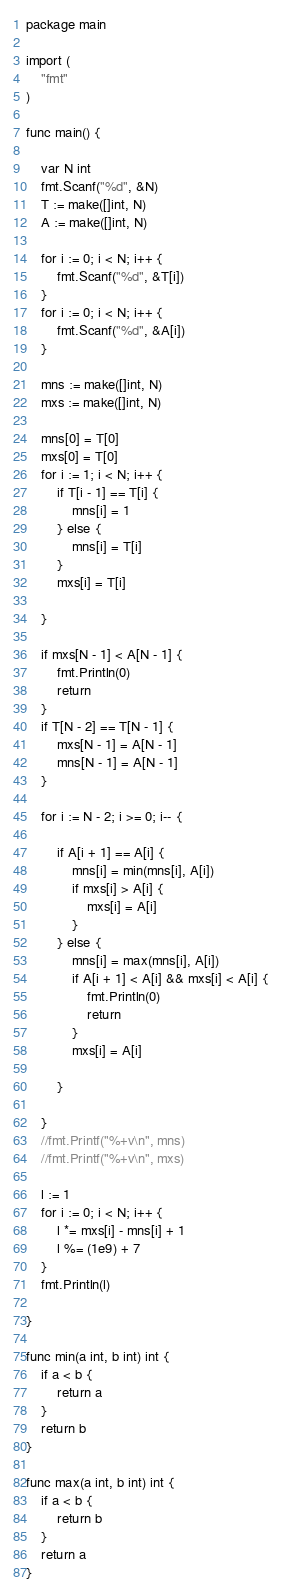<code> <loc_0><loc_0><loc_500><loc_500><_Go_>package main

import (
	"fmt"
)

func main() {

	var N int
	fmt.Scanf("%d", &N)
	T := make([]int, N)
	A := make([]int, N)

	for i := 0; i < N; i++ {
		fmt.Scanf("%d", &T[i])
	}
	for i := 0; i < N; i++ {
		fmt.Scanf("%d", &A[i])
	}

	mns := make([]int, N)
	mxs := make([]int, N)

	mns[0] = T[0]
	mxs[0] = T[0]
	for i := 1; i < N; i++ {
		if T[i - 1] == T[i] {
			mns[i] = 1
		} else {
			mns[i] = T[i]
		}
		mxs[i] = T[i]

	}

	if mxs[N - 1] < A[N - 1] {
		fmt.Println(0)
		return
	}
	if T[N - 2] == T[N - 1] {
		mxs[N - 1] = A[N - 1]
		mns[N - 1] = A[N - 1]
	}

	for i := N - 2; i >= 0; i-- {

		if A[i + 1] == A[i] {
			mns[i] = min(mns[i], A[i])
			if mxs[i] > A[i] {
				mxs[i] = A[i]
			}
		} else {
			mns[i] = max(mns[i], A[i])
			if A[i + 1] < A[i] && mxs[i] < A[i] {
				fmt.Println(0)
				return
			}
			mxs[i] = A[i]

		}

	}
	//fmt.Printf("%+v\n", mns)
	//fmt.Printf("%+v\n", mxs)

	l := 1
	for i := 0; i < N; i++ {
		l *= mxs[i] - mns[i] + 1
		l %= (1e9) + 7
	}
	fmt.Println(l)

}

func min(a int, b int) int {
	if a < b {
		return a
	}
	return b
}

func max(a int, b int) int {
	if a < b {
		return b
	}
	return a
}
</code> 